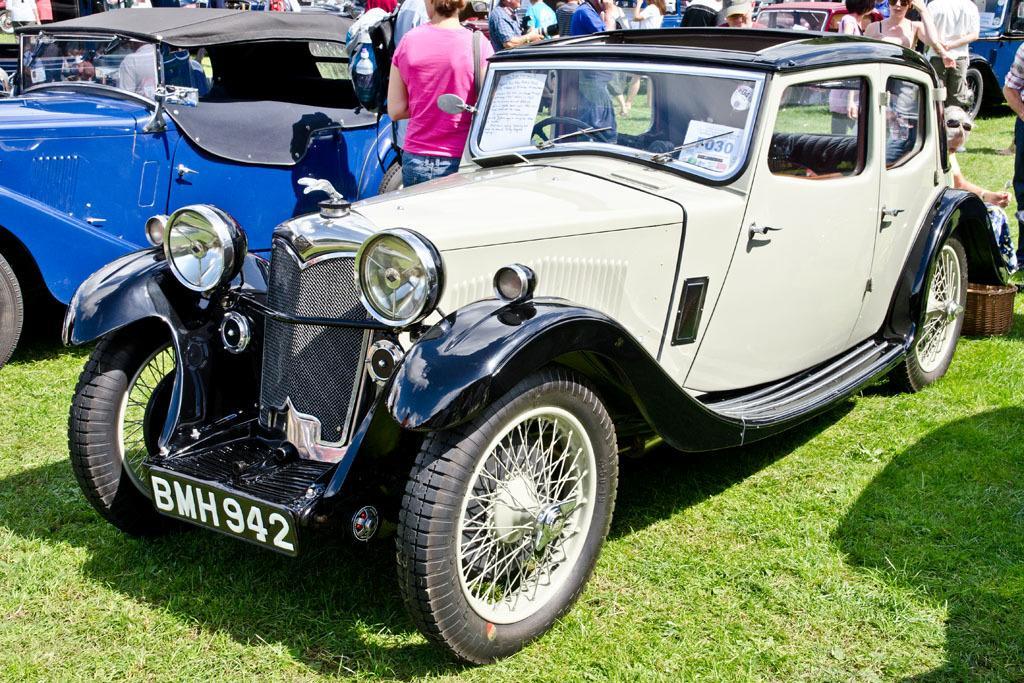Could you give a brief overview of what you see in this image? Here we can see vehicles on the ground. In the background there are few persons standing and carrying bags on their shoulders and on the right we can see a basket on the ground. 